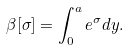<formula> <loc_0><loc_0><loc_500><loc_500>\beta [ \sigma ] = \int _ { 0 } ^ { a } e ^ { \sigma } d y .</formula> 